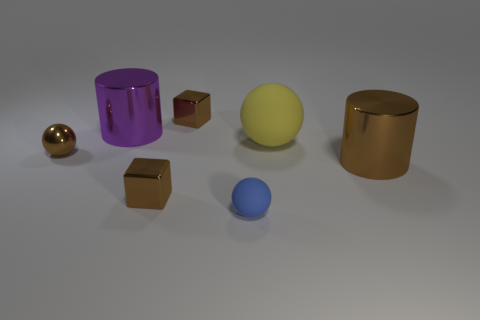What materials could these objects be imitating? The objects in the image could be imitating materials like polished metals for the gold and bronze cylinders and the small sphere, while the cube and the larger sphere might represent materials with a matte finish like plastic or ceramic. 